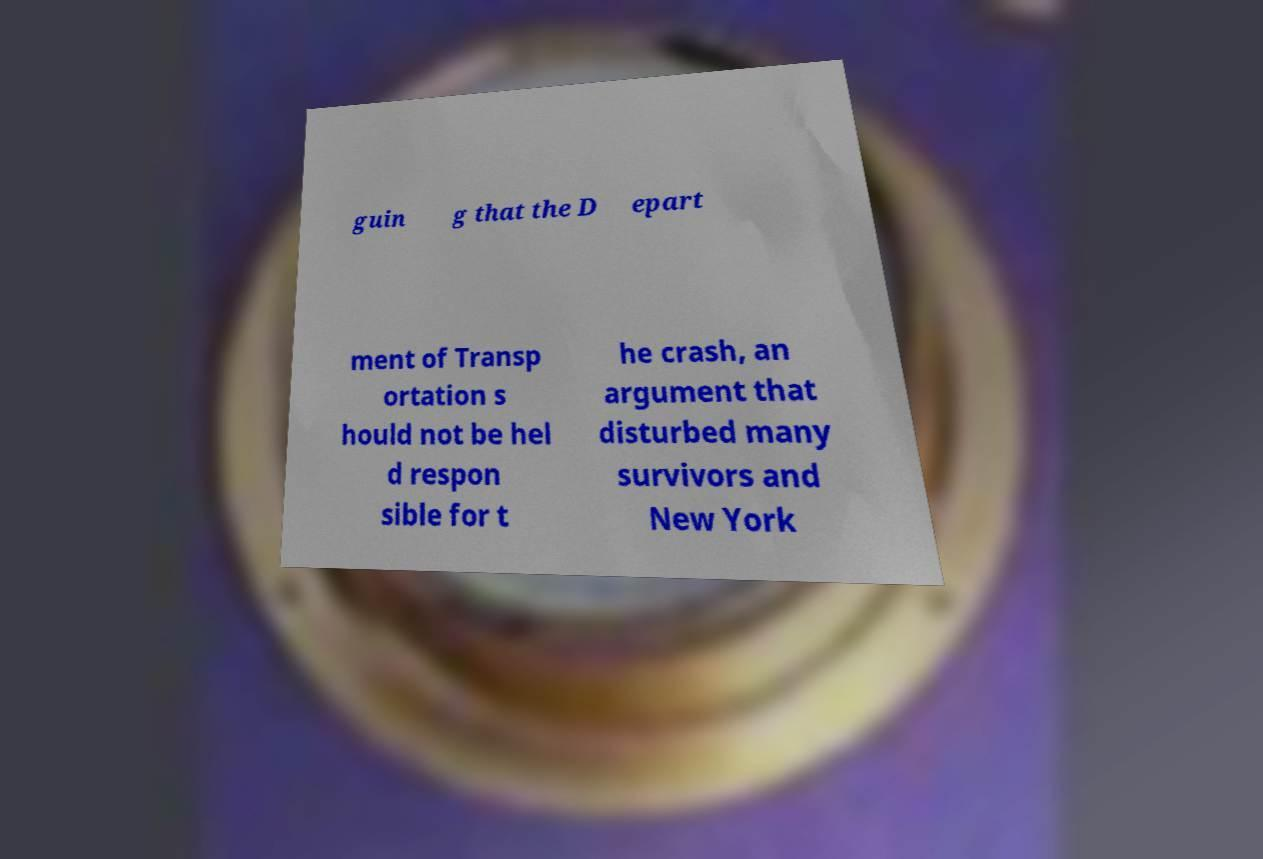Could you extract and type out the text from this image? guin g that the D epart ment of Transp ortation s hould not be hel d respon sible for t he crash, an argument that disturbed many survivors and New York 